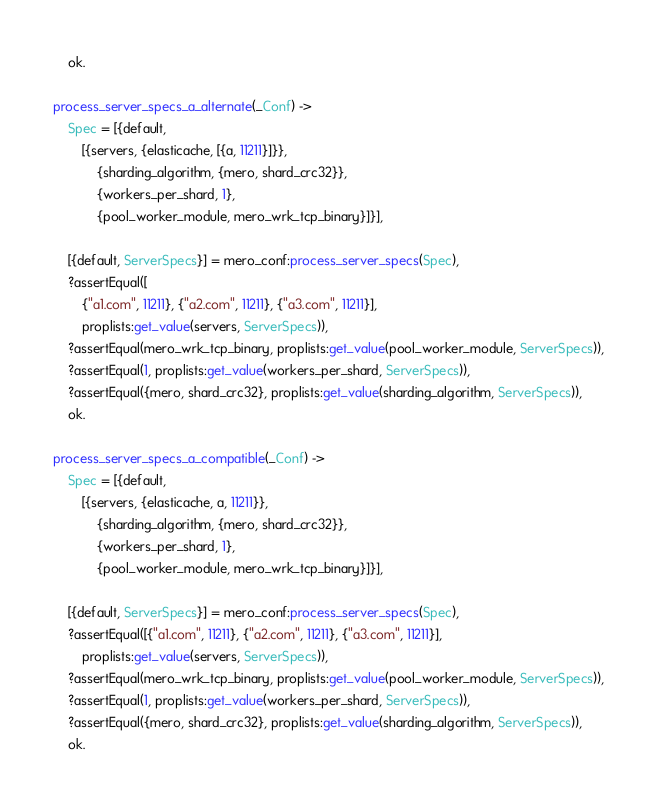Convert code to text. <code><loc_0><loc_0><loc_500><loc_500><_Erlang_>    ok.

process_server_specs_a_alternate(_Conf) ->
    Spec = [{default,
        [{servers, {elasticache, [{a, 11211}]}},
            {sharding_algorithm, {mero, shard_crc32}},
            {workers_per_shard, 1},
            {pool_worker_module, mero_wrk_tcp_binary}]}],

    [{default, ServerSpecs}] = mero_conf:process_server_specs(Spec),
    ?assertEqual([
        {"a1.com", 11211}, {"a2.com", 11211}, {"a3.com", 11211}],
        proplists:get_value(servers, ServerSpecs)),
    ?assertEqual(mero_wrk_tcp_binary, proplists:get_value(pool_worker_module, ServerSpecs)),
    ?assertEqual(1, proplists:get_value(workers_per_shard, ServerSpecs)),
    ?assertEqual({mero, shard_crc32}, proplists:get_value(sharding_algorithm, ServerSpecs)),
    ok.

process_server_specs_a_compatible(_Conf) ->
    Spec = [{default,
        [{servers, {elasticache, a, 11211}},
            {sharding_algorithm, {mero, shard_crc32}},
            {workers_per_shard, 1},
            {pool_worker_module, mero_wrk_tcp_binary}]}],

    [{default, ServerSpecs}] = mero_conf:process_server_specs(Spec),
    ?assertEqual([{"a1.com", 11211}, {"a2.com", 11211}, {"a3.com", 11211}],
        proplists:get_value(servers, ServerSpecs)),
    ?assertEqual(mero_wrk_tcp_binary, proplists:get_value(pool_worker_module, ServerSpecs)),
    ?assertEqual(1, proplists:get_value(workers_per_shard, ServerSpecs)),
    ?assertEqual({mero, shard_crc32}, proplists:get_value(sharding_algorithm, ServerSpecs)),
    ok.
</code> 